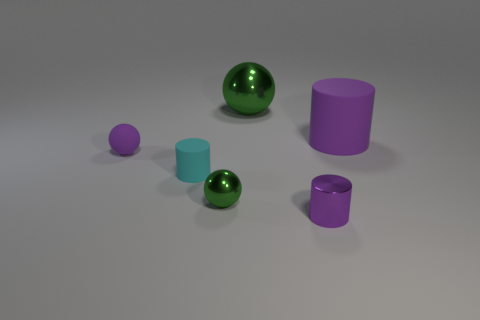Are there fewer small brown shiny balls than rubber cylinders?
Ensure brevity in your answer.  Yes. What material is the cylinder that is in front of the tiny purple rubber object and right of the tiny green thing?
Your answer should be very brief. Metal. There is a tiny purple metallic cylinder that is in front of the large green thing; is there a large cylinder that is in front of it?
Your response must be concise. No. How many things are yellow shiny blocks or tiny objects?
Keep it short and to the point. 4. There is a thing that is both to the left of the large sphere and right of the small matte cylinder; what is its shape?
Make the answer very short. Sphere. Are the ball that is behind the big cylinder and the tiny cyan cylinder made of the same material?
Make the answer very short. No. How many things are either big purple cylinders or cylinders that are to the left of the big cylinder?
Provide a short and direct response. 3. There is a tiny cylinder that is the same material as the purple sphere; what color is it?
Your answer should be very brief. Cyan. What number of tiny purple spheres are the same material as the small cyan cylinder?
Provide a succinct answer. 1. How many large spheres are there?
Provide a succinct answer. 1. 